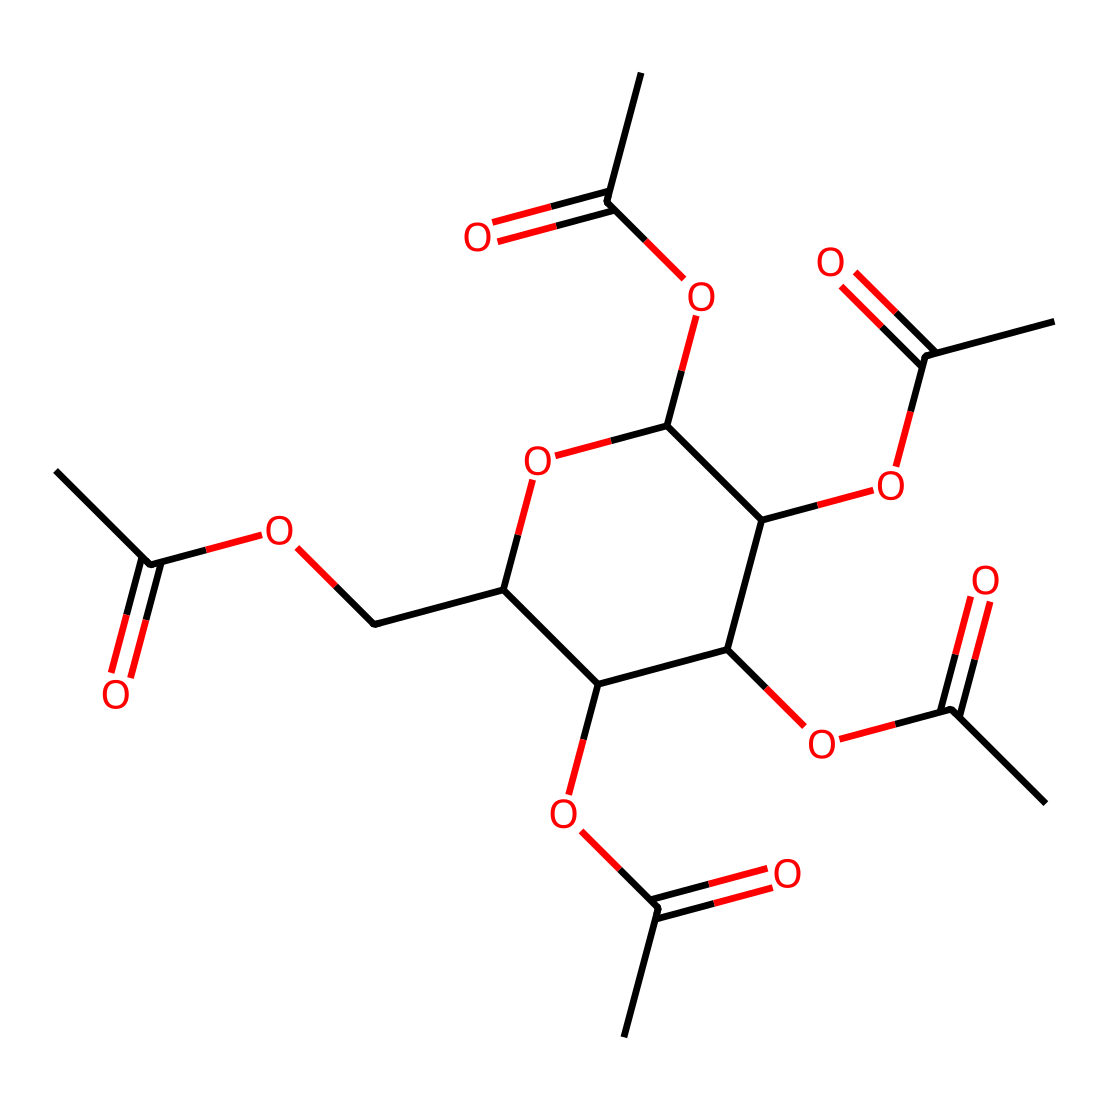What is the main functional group present in cellulose acetate? The chemical structure shows multiple acetyl groups (-COCH3) connected to the cellulose backbone. This indicates that the primary functionality of cellulose acetate is acetylation.
Answer: acetyl How many carbon atoms are present in the structure? By analyzing the SMILES representation, we can count the number of carbon (C) symbols. There are a total of 14 carbon atoms after parsing the entire structure.
Answer: 14 What type of polymer is cellulose acetate classified as? Cellulose acetate is derived from cellulose, which is a polysaccharide. The presence of multiple ether and ester linkages confirms its classification as a thermoplastic polymer.
Answer: thermoplastic How many ester linkages are present in cellulose acetate? The chemical structure reveals that there are four acetyl groups attached to the cellulose unit, indicating the presence of four ester linkages formed by esterification with acetic acid.
Answer: 4 Is cellulose acetate soluble in water? The chemical structure's acetyl groups decrease water solubility compared to cellulose. Thus, cellulose acetate is known to be soluble in organic solvents rather than water.
Answer: no What is one common use of cellulose acetate in filmmaking? Cellulose acetate is widely used as a base material for photographic film due to its stable properties and clarity. Therefore, its application is primarily for making film stock.
Answer: photographic film 